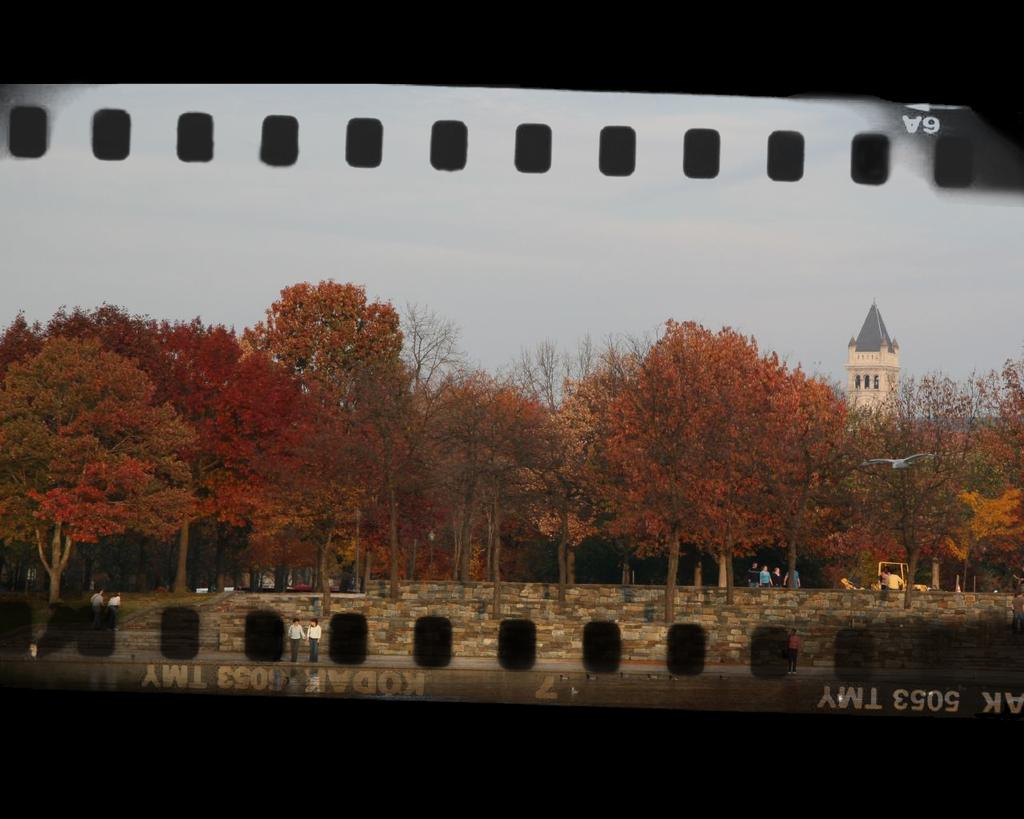<image>
Offer a succinct explanation of the picture presented. Some Kodak 5053 TMY film shows a fall scene 